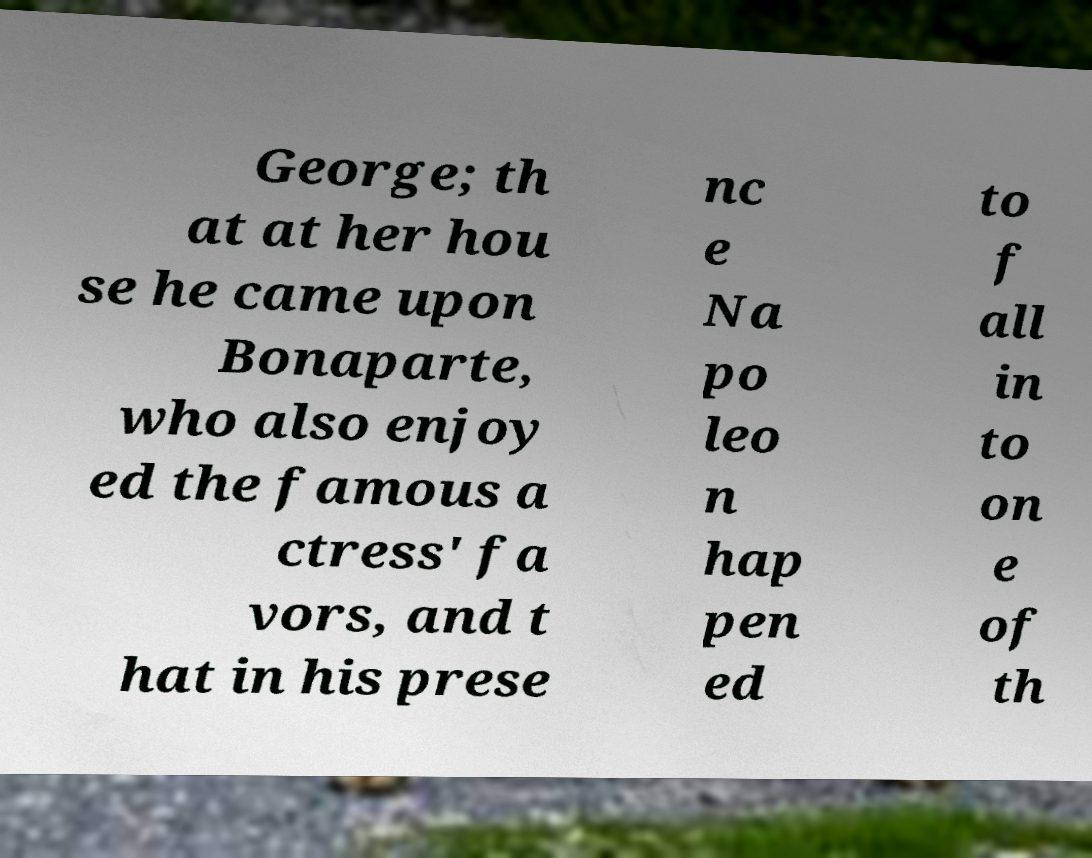Please identify and transcribe the text found in this image. George; th at at her hou se he came upon Bonaparte, who also enjoy ed the famous a ctress' fa vors, and t hat in his prese nc e Na po leo n hap pen ed to f all in to on e of th 